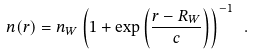Convert formula to latex. <formula><loc_0><loc_0><loc_500><loc_500>n ( { r } ) = n _ { W } \left ( 1 + \exp \left ( \frac { r - R _ { W } } { c } \right ) \right ) ^ { - 1 } \ .</formula> 